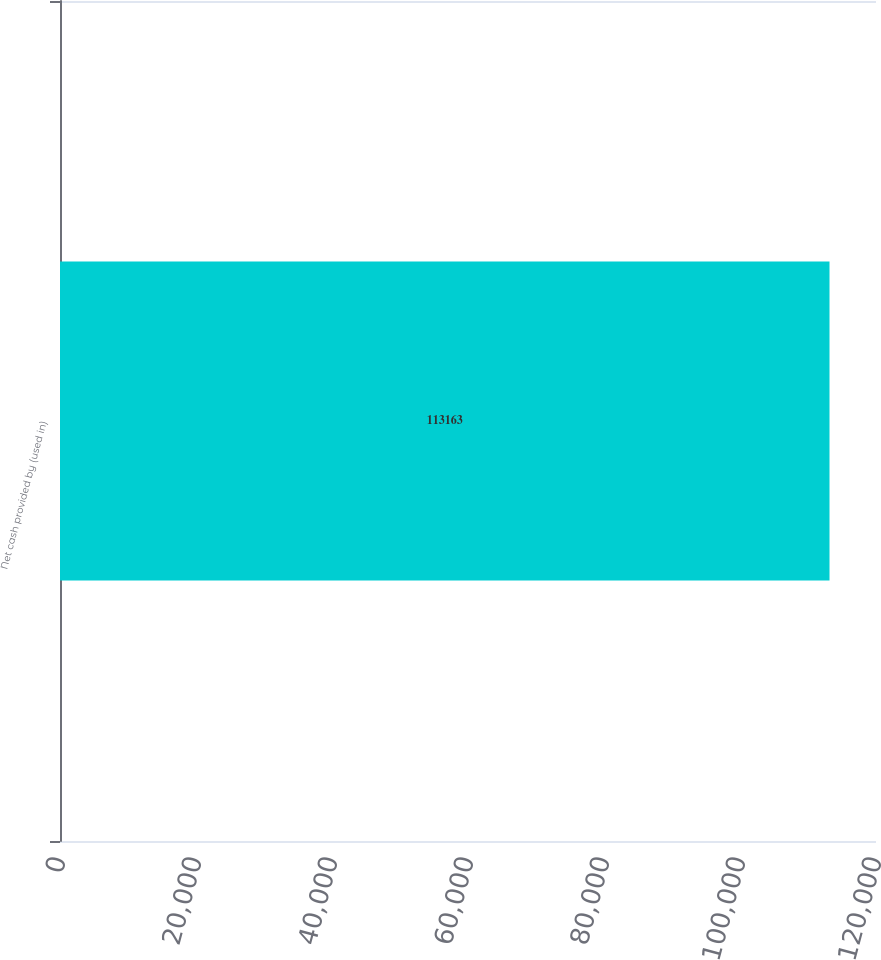Convert chart. <chart><loc_0><loc_0><loc_500><loc_500><bar_chart><fcel>Net cash provided by (used in)<nl><fcel>113163<nl></chart> 